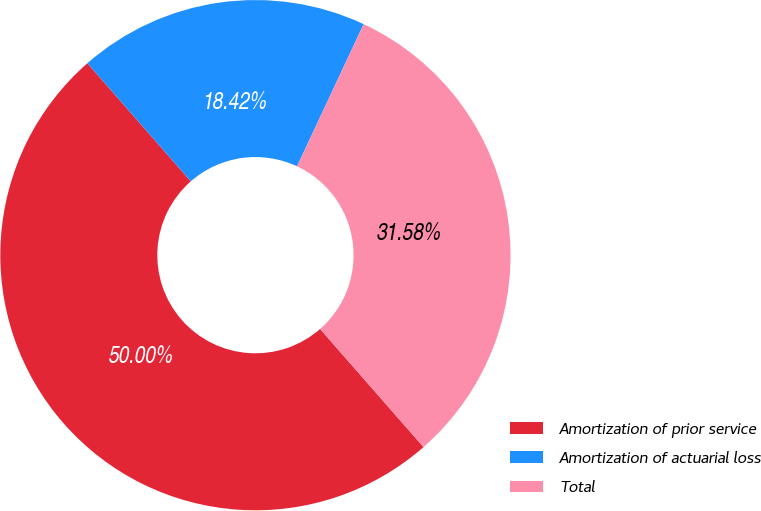<chart> <loc_0><loc_0><loc_500><loc_500><pie_chart><fcel>Amortization of prior service<fcel>Amortization of actuarial loss<fcel>Total<nl><fcel>50.0%<fcel>18.42%<fcel>31.58%<nl></chart> 